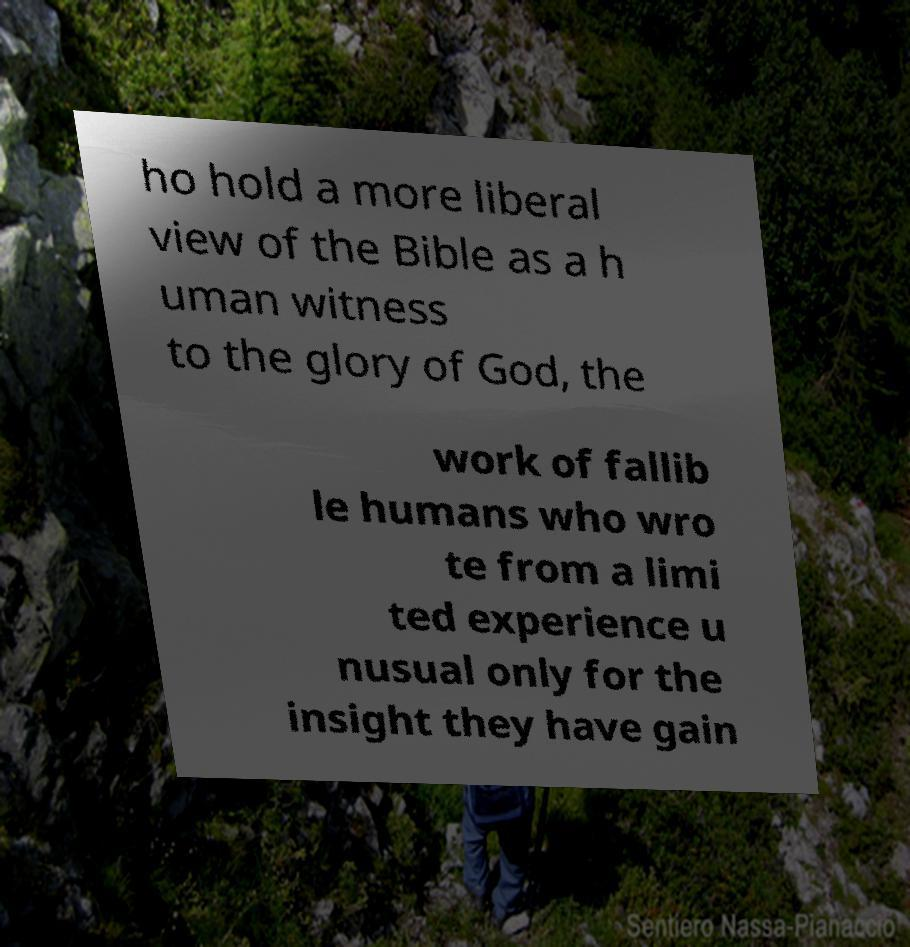Could you extract and type out the text from this image? ho hold a more liberal view of the Bible as a h uman witness to the glory of God, the work of fallib le humans who wro te from a limi ted experience u nusual only for the insight they have gain 